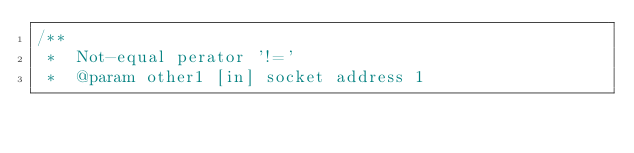Convert code to text. <code><loc_0><loc_0><loc_500><loc_500><_C++_>/**
 *  Not-equal perator '!='
 *  @param other1 [in] socket address 1</code> 